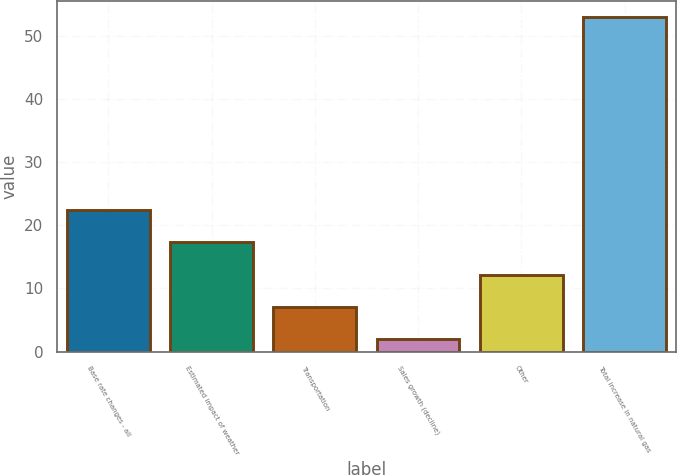Convert chart to OTSL. <chart><loc_0><loc_0><loc_500><loc_500><bar_chart><fcel>Base rate changes - all<fcel>Estimated impact of weather<fcel>Transportation<fcel>Sales growth (decline)<fcel>Other<fcel>Total increase in natural gas<nl><fcel>22.4<fcel>17.3<fcel>7.1<fcel>2<fcel>12.2<fcel>53<nl></chart> 